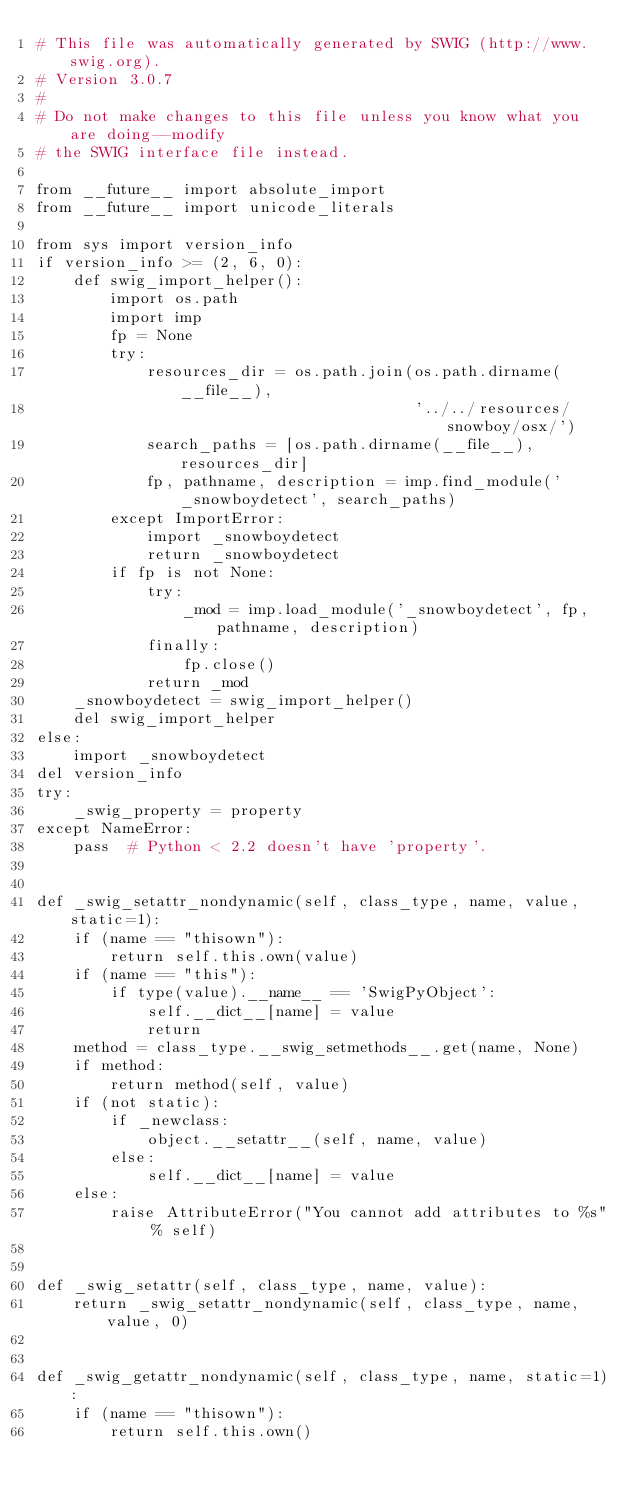<code> <loc_0><loc_0><loc_500><loc_500><_Python_># This file was automatically generated by SWIG (http://www.swig.org).
# Version 3.0.7
#
# Do not make changes to this file unless you know what you are doing--modify
# the SWIG interface file instead.

from __future__ import absolute_import
from __future__ import unicode_literals

from sys import version_info
if version_info >= (2, 6, 0):
    def swig_import_helper():
        import os.path
        import imp
        fp = None
        try:
            resources_dir = os.path.join(os.path.dirname(__file__),
                                         '../../resources/snowboy/osx/')
            search_paths = [os.path.dirname(__file__), resources_dir]
            fp, pathname, description = imp.find_module('_snowboydetect', search_paths)
        except ImportError:
            import _snowboydetect
            return _snowboydetect
        if fp is not None:
            try:
                _mod = imp.load_module('_snowboydetect', fp, pathname, description)
            finally:
                fp.close()
            return _mod
    _snowboydetect = swig_import_helper()
    del swig_import_helper
else:
    import _snowboydetect
del version_info
try:
    _swig_property = property
except NameError:
    pass  # Python < 2.2 doesn't have 'property'.


def _swig_setattr_nondynamic(self, class_type, name, value, static=1):
    if (name == "thisown"):
        return self.this.own(value)
    if (name == "this"):
        if type(value).__name__ == 'SwigPyObject':
            self.__dict__[name] = value
            return
    method = class_type.__swig_setmethods__.get(name, None)
    if method:
        return method(self, value)
    if (not static):
        if _newclass:
            object.__setattr__(self, name, value)
        else:
            self.__dict__[name] = value
    else:
        raise AttributeError("You cannot add attributes to %s" % self)


def _swig_setattr(self, class_type, name, value):
    return _swig_setattr_nondynamic(self, class_type, name, value, 0)


def _swig_getattr_nondynamic(self, class_type, name, static=1):
    if (name == "thisown"):
        return self.this.own()</code> 